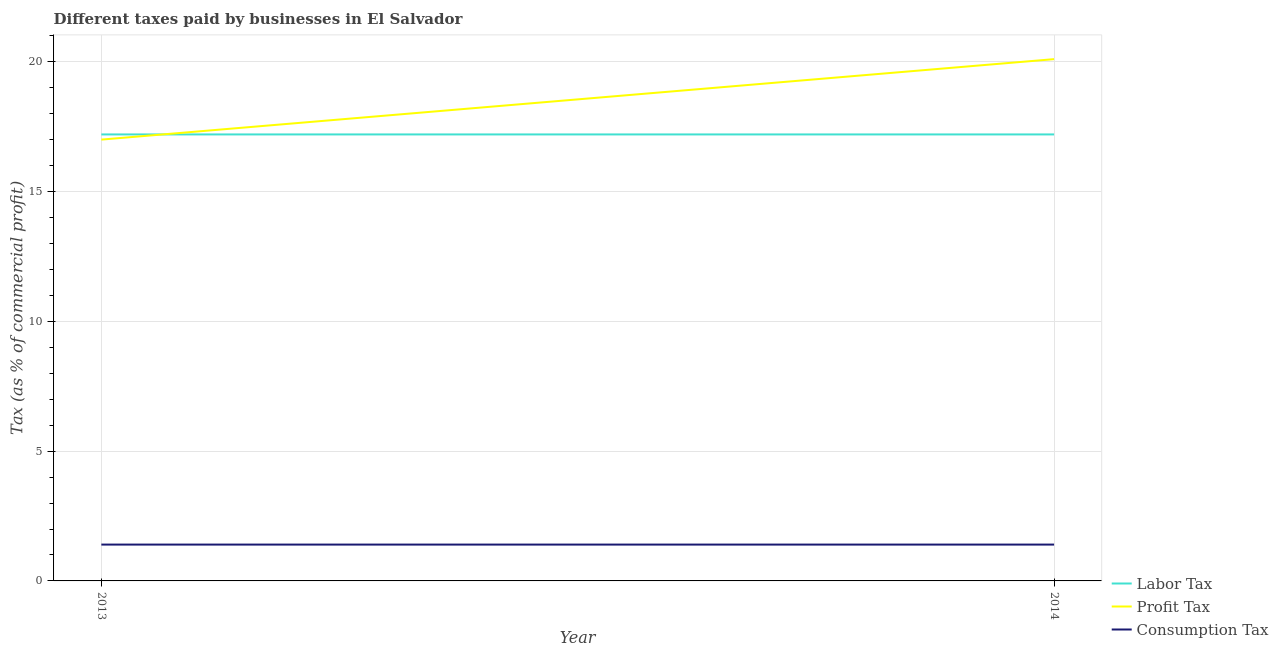Across all years, what is the maximum percentage of labor tax?
Offer a very short reply. 17.2. What is the total percentage of labor tax in the graph?
Your answer should be compact. 34.4. What is the difference between the percentage of profit tax in 2013 and that in 2014?
Offer a terse response. -3.1. What is the difference between the percentage of consumption tax in 2013 and the percentage of profit tax in 2014?
Your answer should be very brief. -18.7. What is the average percentage of labor tax per year?
Ensure brevity in your answer.  17.2. In the year 2013, what is the difference between the percentage of consumption tax and percentage of labor tax?
Your response must be concise. -15.8. In how many years, is the percentage of labor tax greater than 20 %?
Offer a very short reply. 0. Is it the case that in every year, the sum of the percentage of labor tax and percentage of profit tax is greater than the percentage of consumption tax?
Keep it short and to the point. Yes. Is the percentage of consumption tax strictly less than the percentage of labor tax over the years?
Keep it short and to the point. Yes. How many lines are there?
Your response must be concise. 3. What is the difference between two consecutive major ticks on the Y-axis?
Offer a terse response. 5. Are the values on the major ticks of Y-axis written in scientific E-notation?
Provide a succinct answer. No. Where does the legend appear in the graph?
Offer a terse response. Bottom right. How many legend labels are there?
Offer a very short reply. 3. How are the legend labels stacked?
Make the answer very short. Vertical. What is the title of the graph?
Provide a succinct answer. Different taxes paid by businesses in El Salvador. Does "Resident buildings and public services" appear as one of the legend labels in the graph?
Provide a short and direct response. No. What is the label or title of the Y-axis?
Make the answer very short. Tax (as % of commercial profit). What is the Tax (as % of commercial profit) of Labor Tax in 2013?
Provide a short and direct response. 17.2. What is the Tax (as % of commercial profit) in Labor Tax in 2014?
Keep it short and to the point. 17.2. What is the Tax (as % of commercial profit) in Profit Tax in 2014?
Offer a terse response. 20.1. Across all years, what is the maximum Tax (as % of commercial profit) in Profit Tax?
Offer a very short reply. 20.1. Across all years, what is the minimum Tax (as % of commercial profit) in Labor Tax?
Provide a succinct answer. 17.2. Across all years, what is the minimum Tax (as % of commercial profit) of Profit Tax?
Make the answer very short. 17. What is the total Tax (as % of commercial profit) of Labor Tax in the graph?
Your answer should be compact. 34.4. What is the total Tax (as % of commercial profit) in Profit Tax in the graph?
Make the answer very short. 37.1. What is the difference between the Tax (as % of commercial profit) of Labor Tax in 2013 and that in 2014?
Make the answer very short. 0. What is the difference between the Tax (as % of commercial profit) of Labor Tax in 2013 and the Tax (as % of commercial profit) of Profit Tax in 2014?
Your answer should be very brief. -2.9. What is the difference between the Tax (as % of commercial profit) in Labor Tax in 2013 and the Tax (as % of commercial profit) in Consumption Tax in 2014?
Give a very brief answer. 15.8. What is the average Tax (as % of commercial profit) in Labor Tax per year?
Your answer should be compact. 17.2. What is the average Tax (as % of commercial profit) of Profit Tax per year?
Offer a very short reply. 18.55. In the year 2013, what is the difference between the Tax (as % of commercial profit) of Labor Tax and Tax (as % of commercial profit) of Profit Tax?
Your answer should be very brief. 0.2. In the year 2013, what is the difference between the Tax (as % of commercial profit) in Labor Tax and Tax (as % of commercial profit) in Consumption Tax?
Your answer should be very brief. 15.8. In the year 2014, what is the difference between the Tax (as % of commercial profit) of Profit Tax and Tax (as % of commercial profit) of Consumption Tax?
Your response must be concise. 18.7. What is the ratio of the Tax (as % of commercial profit) of Profit Tax in 2013 to that in 2014?
Keep it short and to the point. 0.85. What is the ratio of the Tax (as % of commercial profit) in Consumption Tax in 2013 to that in 2014?
Keep it short and to the point. 1. What is the difference between the highest and the second highest Tax (as % of commercial profit) of Labor Tax?
Offer a very short reply. 0. What is the difference between the highest and the lowest Tax (as % of commercial profit) of Consumption Tax?
Provide a short and direct response. 0. 